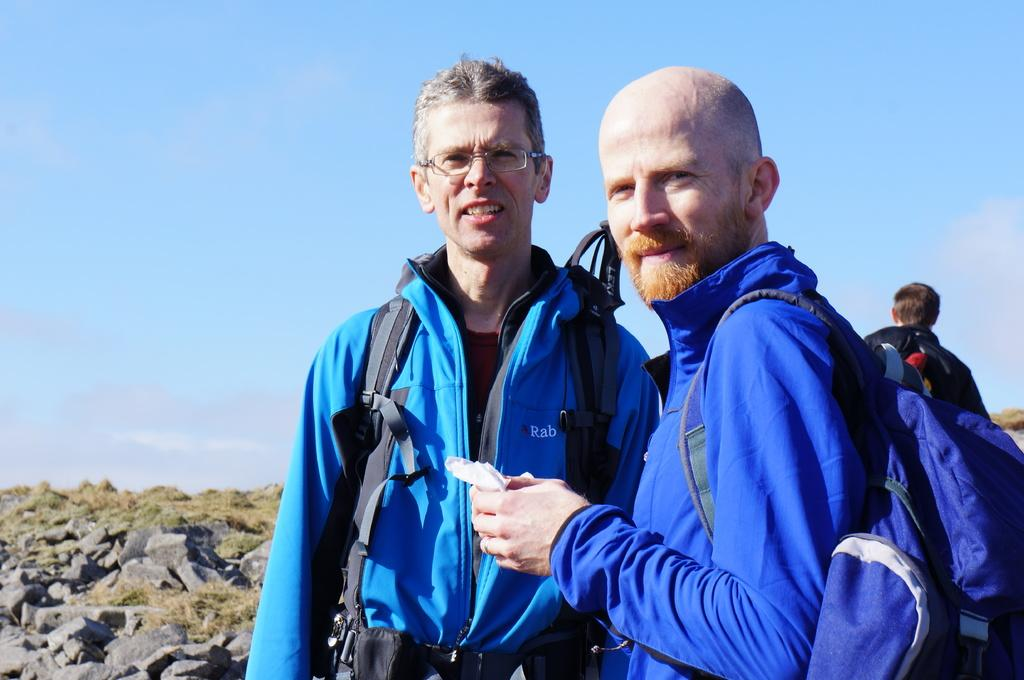How many people are in the image? There are two men in the image. What are the men wearing? The men are wearing blue sweaters. What can be seen on the left side of the image? There are stones on the left side of the image. What is visible at the top of the image? The sky is visible at the top of the image. What type of sign can be seen in the image? There is no sign present in the image. Is the area depicted in the image quiet or noisy? The image does not provide any information about the noise level in the area. 